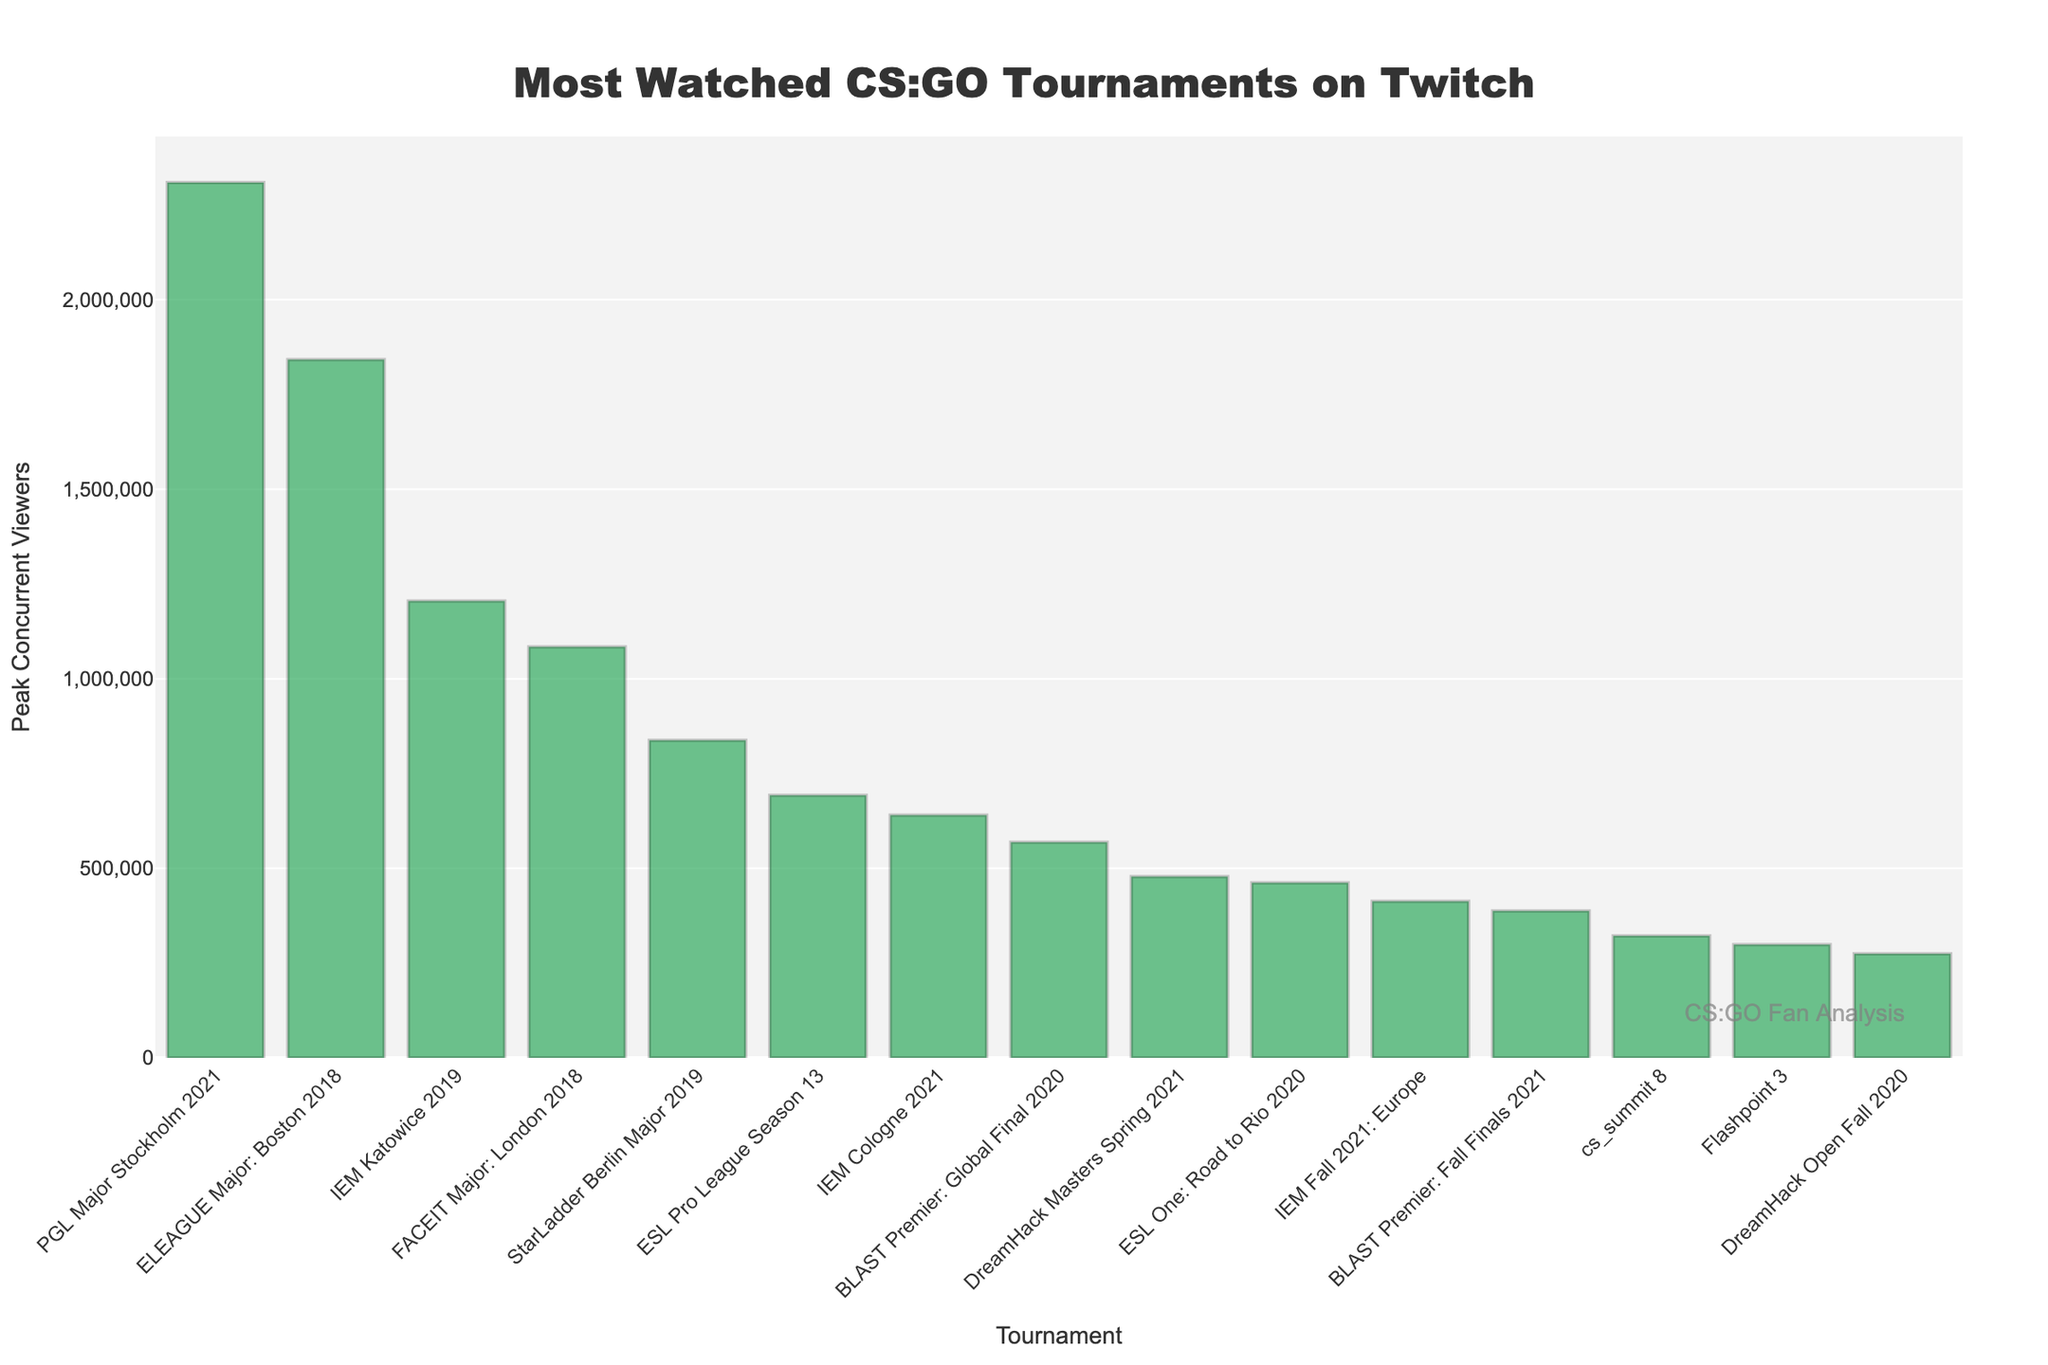Which tournament had the highest peak concurrent viewers? By looking at the height of the bars, it's clear that the PGL Major Stockholm 2021 bar is the tallest, indicating it had the highest peak concurrent viewers.
Answer: PGL Major Stockholm 2021 How many more peak concurrent viewers did PGL Major Stockholm 2021 have compared to ELEAGUE Major: Boston 2018? The bar for PGL Major Stockholm 2021 reaches 2,308,988 viewers, and the bar for ELEAGUE Major: Boston 2018 reaches 1,842,265 viewers. The difference is 2,308,988 - 1,842,265.
Answer: 466,723 Which tournament had the lowest peak concurrent viewers? The shortest bar represents the DreamHack Open Fall 2020 tournament, indicating it had the lowest peak concurrent viewers.
Answer: DreamHack Open Fall 2020 What is the combined total peak concurrent viewers of the top three tournaments? The peak concurrent viewers for the top three tournaments are PGL Major Stockholm 2021 with 2,308,988, ELEAGUE Major: Boston 2018 with 1,842,265, and IEM Katowice 2019 with 1,205,103. Adding these together: 2,308,988 + 1,842,265 + 1,205,103.
Answer: 5,356,356 How many tournaments had peak concurrent viewers above 1 million? By counting the bars that extend above the 1,000,000 mark, there are three tournaments: PGL Major Stockholm 2021, ELEAGUE Major: Boston 2018, and IEM Katowice 2019.
Answer: 3 What is the median value of the peak concurrent viewers among the tournaments listed? First, order the peak concurrent viewers from smallest to largest: 274,813; 298,941; 321,657; 387,522; 412,876; 461,964; 478,291; 568,713; 640,305; 692,433; 837,748; 1,084,163; 1,205,103; 1,842,265; 2,308,988. The middle value (8th in the list) is 568,713.
Answer: 568,713 Which tournament was ranked fifth in terms of peak concurrent viewers? Sort the bar heights in descending order and identify the fifth bar, which corresponds to the StarLadder Berlin Major 2019.
Answer: StarLadder Berlin Major 2019 Did any tournament have peak concurrent viewers between 500,000 and 600,000? By inspecting the bars, the tournament that falls within this range is BLAST Premier: Global Final 2020, with 568,713 peak concurrent viewers.
Answer: Yes What is the average peak concurrent viewers of all the tournaments combined? Summing the peak concurrent viewers for all tournaments gives 12,548,963. There are 15 tournaments, so the average is 12,548,963 / 15.
Answer: 836,598 Compare the peak concurrent viewers of ESL Pro League Season 13 and IEM Cologne 2021. Which one had more? By comparing the heights of the bars, ESL Pro League Season 13 with 692,433 viewers is taller than IEM Cologne 2021 with 640,305 viewers.
Answer: ESL Pro League Season 13 